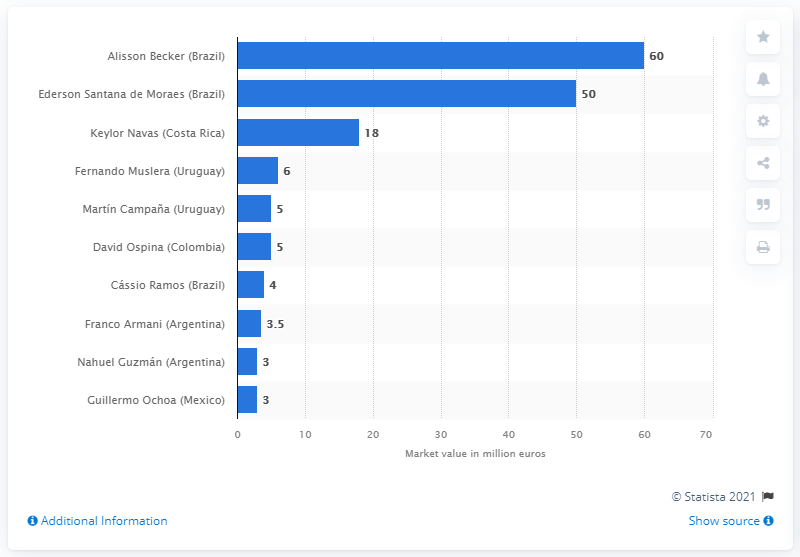Mention a couple of crucial points in this snapshot. What was Ederson's market value? It was estimated to be 50.. 